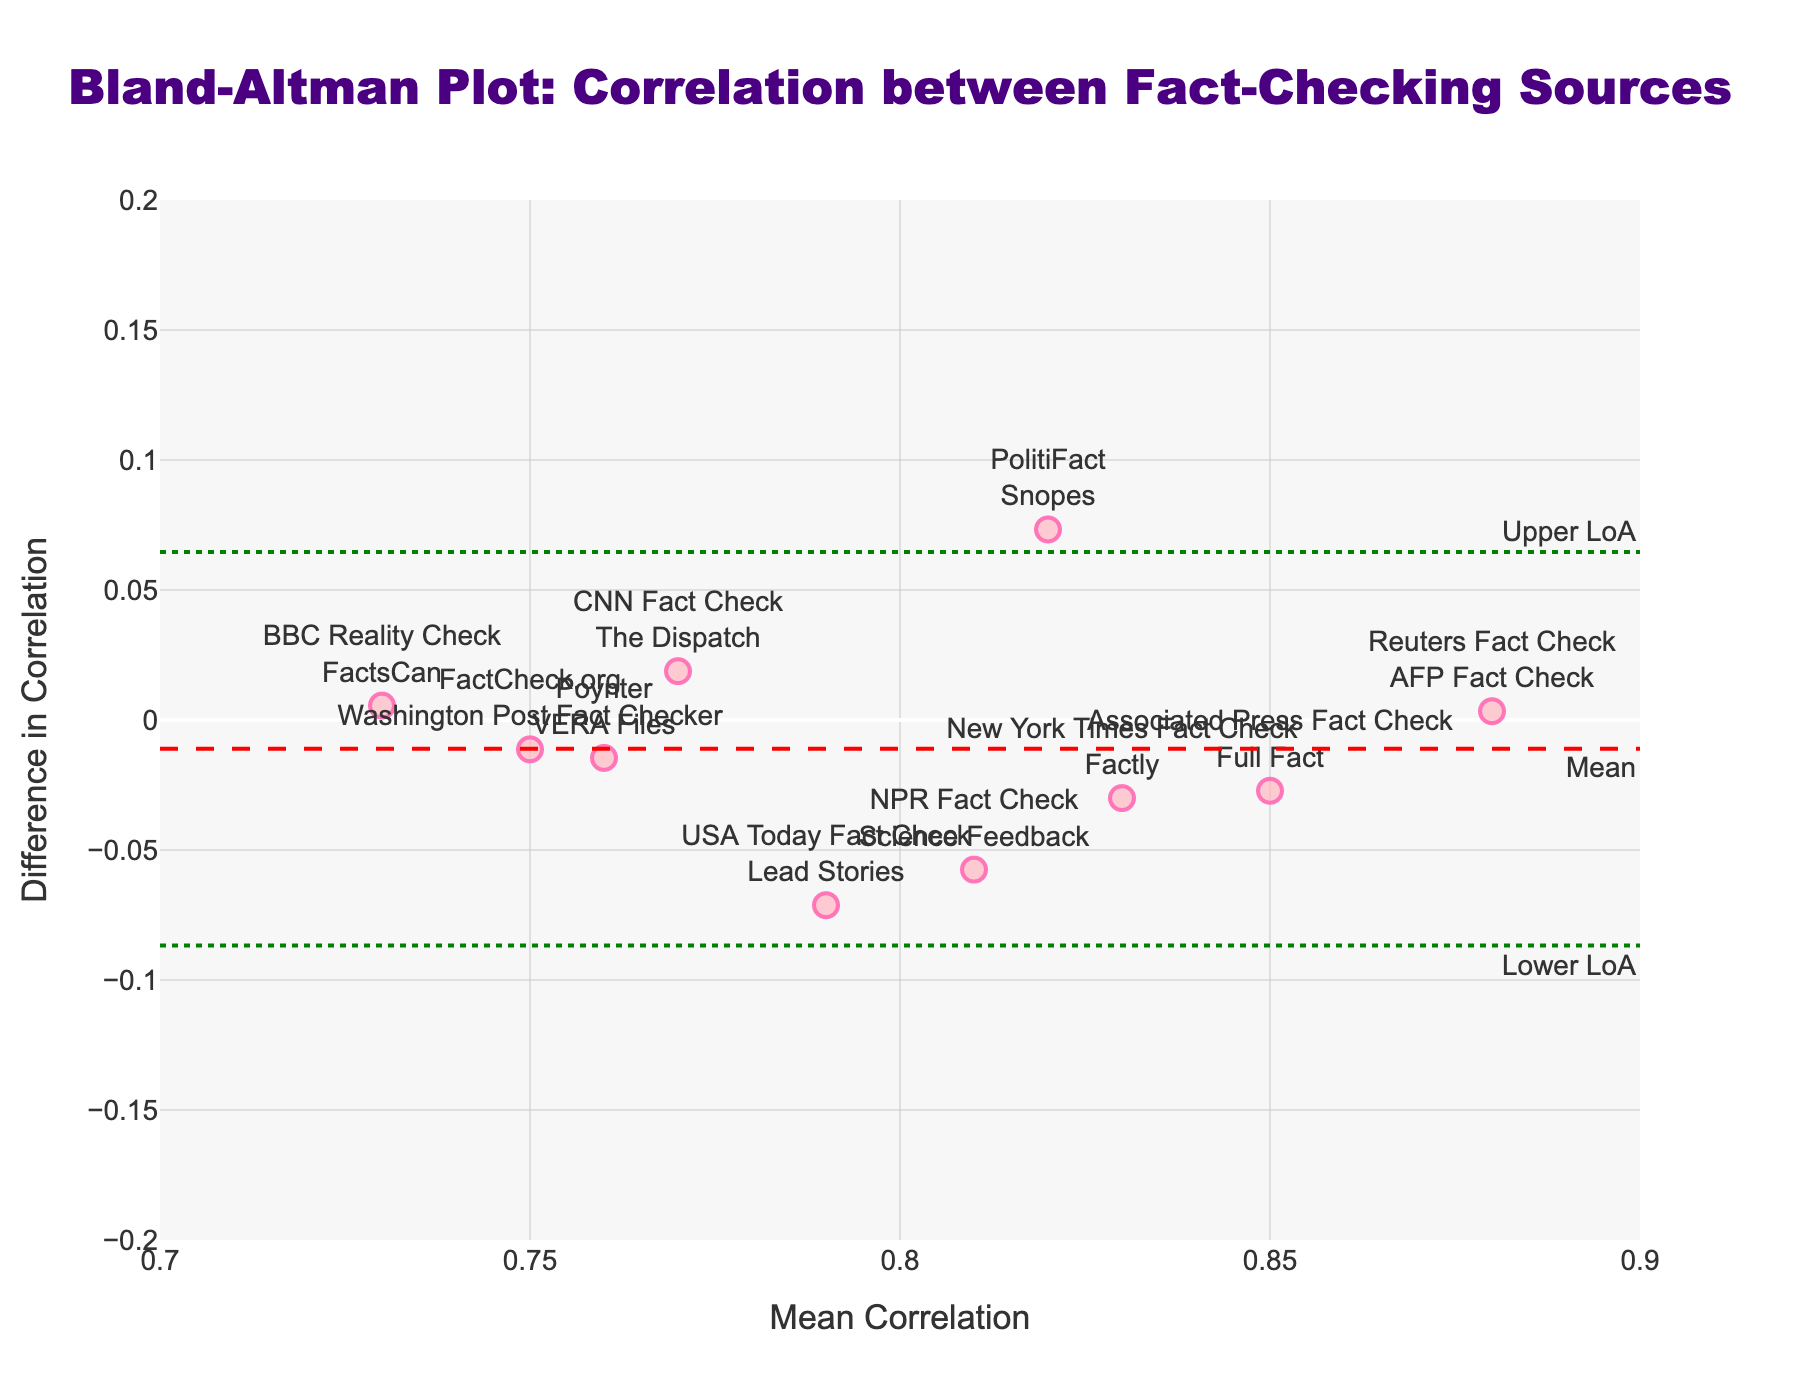What is the title of the figure? The title can be found at the top of the figure, generally in a larger or bold font. It usually provides a summary of what the plot represents.
Answer: Bland-Altman Plot: Correlation between Fact-Checking Sources What do the x-axis and y-axis represent? The x-axis title is labeled "Mean Correlation" which represents the mean correlation between the fact-checking results from different sources. The y-axis title is labeled "Difference in Correlation" which represents the difference in correlation between the fact-checking results from different sources.
Answer: Mean Correlation and Difference in Correlation How many data points are there in the plot? Each marker on the plot represents a data point. By counting the markers, we find the number of data points.
Answer: 10 What color are the data points, and is there any additional distinguishing feature? The data points are a shade of pink, specifically described as 'rgba(255, 182, 193, 0.7)', and they have a prominent border color of 'rgba(255, 105, 180, 0.9)'. They are also marked by a black outline around each point.
Answer: Pink with a black outline What are the values of the upper and lower limits of agreement? The limits of agreement are represented by the horizontal dashed green lines on the plot. These values can be read directly from the y-axis where the lines intersect.
Answer: Approximately +0.098 and -0.088 Which fact-checking sources pair has the highest average correlation? Each data point is labeled with the corresponding fact-checking sources. By examining the x-axis position of the markers, the point furthest to the right corresponds to the highest average correlation.
Answer: Reuters Fact Check & AFP Fact Check Is there any data point close to the mean line, and which fact-checking sources does it represent? The mean line is represented by the dashed red line. We need to find a data point closest to this line and identify the corresponding fact-checking sources.
Answer: Associated Press Fact Check & Full Fact What does the mean line signify in this plot? The mean line represents the average difference in correlation between the fact-checking sources. It is indicated by a dashed red line in the middle of the y-axis.
Answer: Average difference in correlation Which fact-checking sources pair shows the smallest difference in correlation? The smallest difference in correlation is the data point closest to the x-axis (y=0). By examining the corresponding label or hover information, we can identify the sources.
Answer: NPR Fact Check & Science Feedback Do any data points fall outside the limits of agreement? The limits of agreement are indicated by the dotted green lines. We check if any data points (pink markers) fall above the upper limit or below the lower limit lines.
Answer: No 